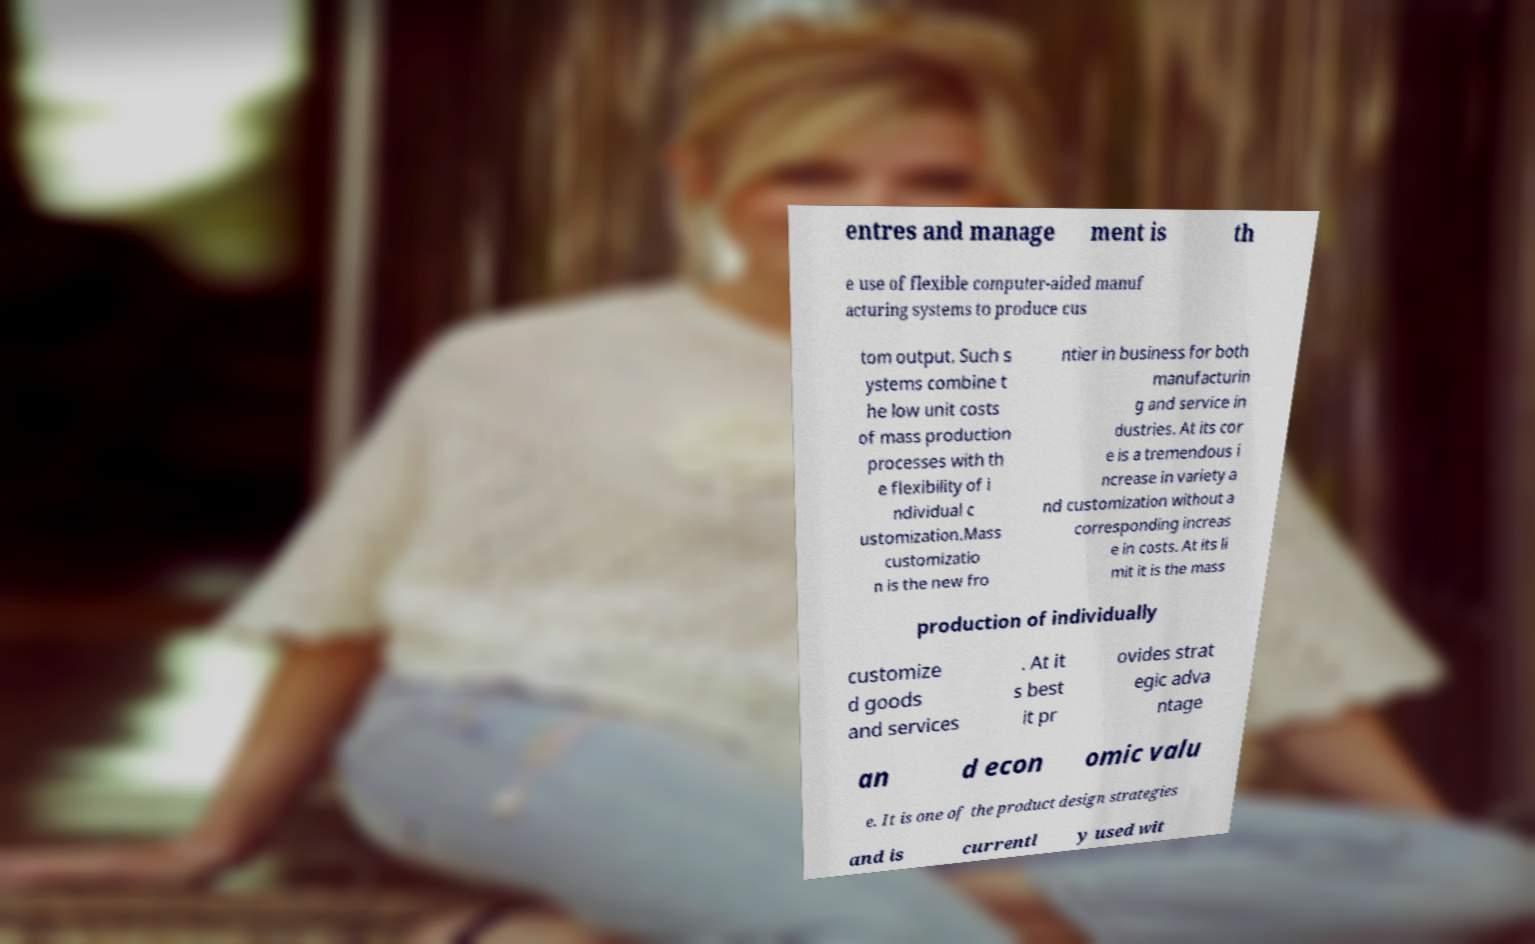Can you read and provide the text displayed in the image?This photo seems to have some interesting text. Can you extract and type it out for me? entres and manage ment is th e use of flexible computer-aided manuf acturing systems to produce cus tom output. Such s ystems combine t he low unit costs of mass production processes with th e flexibility of i ndividual c ustomization.Mass customizatio n is the new fro ntier in business for both manufacturin g and service in dustries. At its cor e is a tremendous i ncrease in variety a nd customization without a corresponding increas e in costs. At its li mit it is the mass production of individually customize d goods and services . At it s best it pr ovides strat egic adva ntage an d econ omic valu e. It is one of the product design strategies and is currentl y used wit 